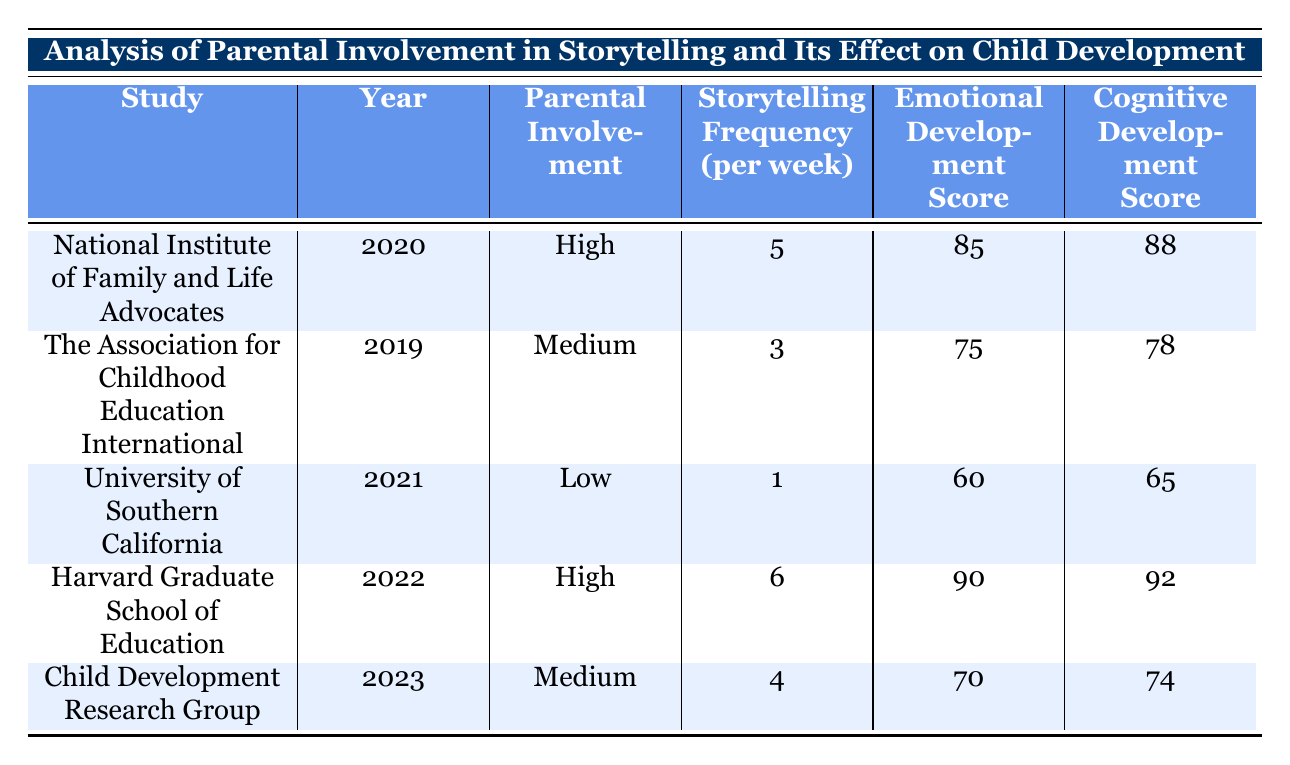What is the emotional development score for the study conducted by the Harvard Graduate School of Education? The emotional development score is a specific value cited in the table for each study. By locating the row corresponding to the Harvard Graduate School of Education, we can see that its emotional development score is 90.
Answer: 90 Which study shows the highest cognitive development score? By examining the cognitive development scores in the table, we can see that the Harvard Graduate School of Education has the highest score at 92.
Answer: Harvard Graduate School of Education What is the average storytelling frequency per week across all studies? To find the average storytelling frequency, we need to sum the storytelling frequencies (5 + 3 + 1 + 6 + 4) = 19, and then divide by the number of studies (5). The average is 19 / 5 = 3.8.
Answer: 3.8 Is parental involvement a factor in the emotional development score according to the table? By analyzing the data, we can see that higher parental involvement is associated with higher emotional development scores (High: 85, Medium: 75, Low: 60). This suggests that parental involvement does indeed impact emotional development.
Answer: Yes What is the difference in emotional development scores between high involvement and low involvement studies? The emotional development score for high involvement (85 for National Institute of Family and Life Advocates and 90 for Harvard) is averaged as (85 + 90) / 2 = 87.5. The low involvement score is 60 from the University of Southern California. The difference is 87.5 - 60 = 27.5.
Answer: 27.5 Which study had the lowest parental involvement? The study with the lowest parental involvement is the University of Southern California, as indicated in the table where it lists its involvement as Low.
Answer: University of Southern California What is the social skills score for the study with medium parental involvement conducted in 2023? Looking at the Child Development Research Group study from 2023, we find that its social skills score is listed as 71.
Answer: 71 Does the data indicate that increased storytelling frequency correlates with emotional development scores? By comparing the storytelling frequency and emotional development scores, we see a trend where a higher frequency (5 and 6 times) is correlated with higher emotional scores (85 and 90), while lower frequency (1 time) correlates with lower emotional score (60). This suggests a positive correlation.
Answer: Yes 